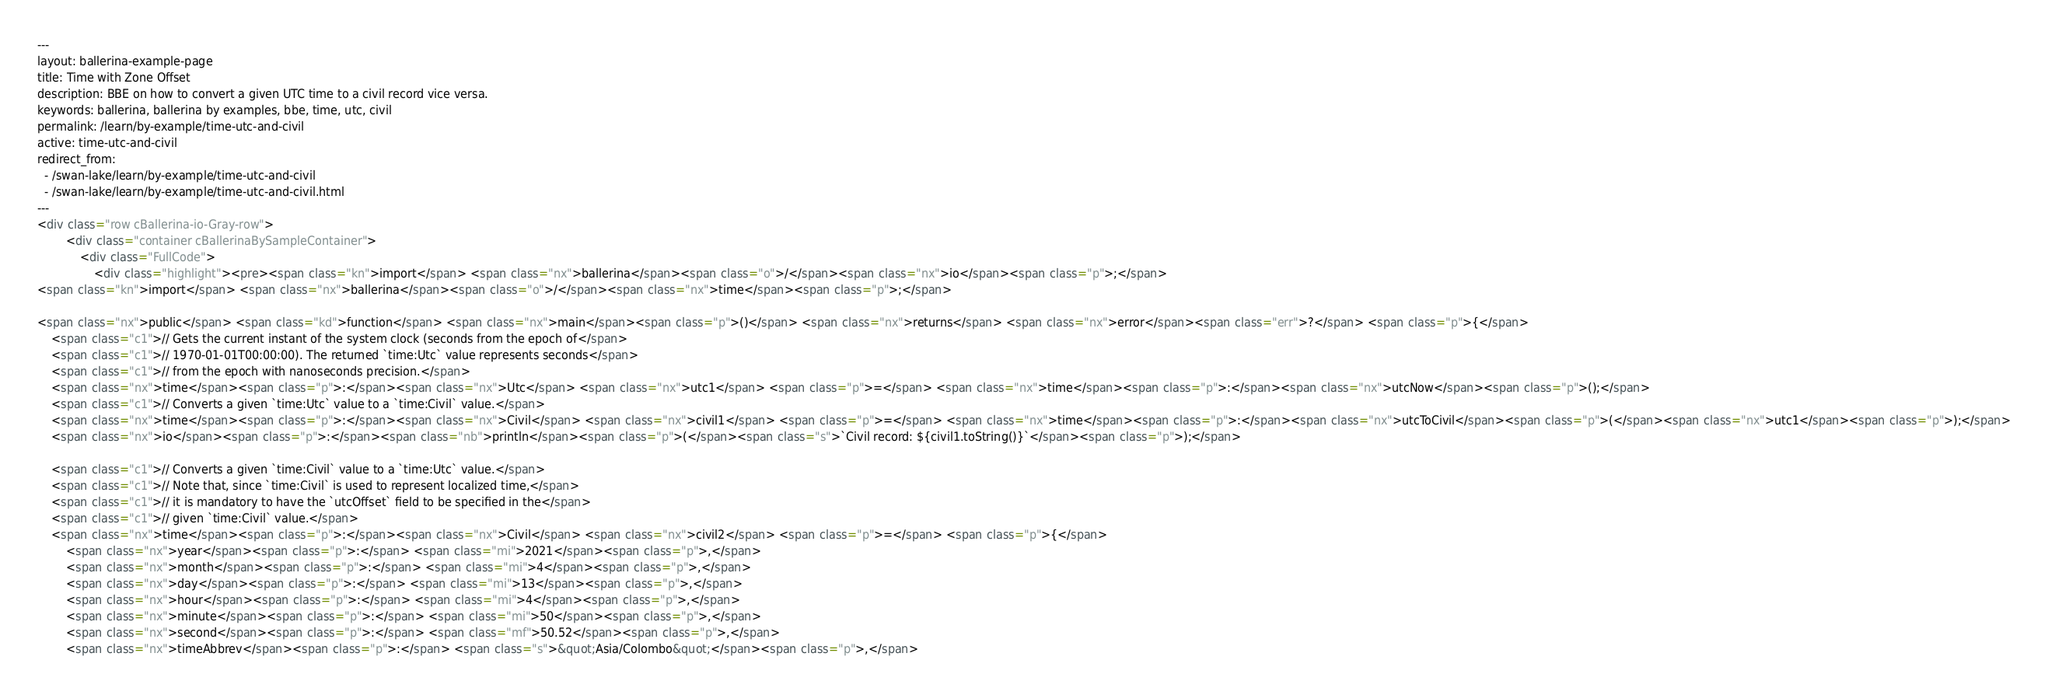Convert code to text. <code><loc_0><loc_0><loc_500><loc_500><_HTML_>---
layout: ballerina-example-page
title: Time with Zone Offset
description: BBE on how to convert a given UTC time to a civil record vice versa.
keywords: ballerina, ballerina by examples, bbe, time, utc, civil
permalink: /learn/by-example/time-utc-and-civil
active: time-utc-and-civil
redirect_from:
  - /swan-lake/learn/by-example/time-utc-and-civil
  - /swan-lake/learn/by-example/time-utc-and-civil.html
---
<div class="row cBallerina-io-Gray-row">
        <div class="container cBallerinaBySampleContainer">
            <div class="FullCode">
                <div class="highlight"><pre><span class="kn">import</span> <span class="nx">ballerina</span><span class="o">/</span><span class="nx">io</span><span class="p">;</span>
<span class="kn">import</span> <span class="nx">ballerina</span><span class="o">/</span><span class="nx">time</span><span class="p">;</span>

<span class="nx">public</span> <span class="kd">function</span> <span class="nx">main</span><span class="p">()</span> <span class="nx">returns</span> <span class="nx">error</span><span class="err">?</span> <span class="p">{</span>
    <span class="c1">// Gets the current instant of the system clock (seconds from the epoch of</span>
    <span class="c1">// 1970-01-01T00:00:00). The returned `time:Utc` value represents seconds</span>
    <span class="c1">// from the epoch with nanoseconds precision.</span>
    <span class="nx">time</span><span class="p">:</span><span class="nx">Utc</span> <span class="nx">utc1</span> <span class="p">=</span> <span class="nx">time</span><span class="p">:</span><span class="nx">utcNow</span><span class="p">();</span>
    <span class="c1">// Converts a given `time:Utc` value to a `time:Civil` value.</span>
    <span class="nx">time</span><span class="p">:</span><span class="nx">Civil</span> <span class="nx">civil1</span> <span class="p">=</span> <span class="nx">time</span><span class="p">:</span><span class="nx">utcToCivil</span><span class="p">(</span><span class="nx">utc1</span><span class="p">);</span>
    <span class="nx">io</span><span class="p">:</span><span class="nb">println</span><span class="p">(</span><span class="s">`Civil record: ${civil1.toString()}`</span><span class="p">);</span>

    <span class="c1">// Converts a given `time:Civil` value to a `time:Utc` value.</span>
    <span class="c1">// Note that, since `time:Civil` is used to represent localized time,</span>
    <span class="c1">// it is mandatory to have the `utcOffset` field to be specified in the</span>
    <span class="c1">// given `time:Civil` value.</span>
    <span class="nx">time</span><span class="p">:</span><span class="nx">Civil</span> <span class="nx">civil2</span> <span class="p">=</span> <span class="p">{</span>
        <span class="nx">year</span><span class="p">:</span> <span class="mi">2021</span><span class="p">,</span>
        <span class="nx">month</span><span class="p">:</span> <span class="mi">4</span><span class="p">,</span>
        <span class="nx">day</span><span class="p">:</span> <span class="mi">13</span><span class="p">,</span>
        <span class="nx">hour</span><span class="p">:</span> <span class="mi">4</span><span class="p">,</span>
        <span class="nx">minute</span><span class="p">:</span> <span class="mi">50</span><span class="p">,</span>
        <span class="nx">second</span><span class="p">:</span> <span class="mf">50.52</span><span class="p">,</span>
        <span class="nx">timeAbbrev</span><span class="p">:</span> <span class="s">&quot;Asia/Colombo&quot;</span><span class="p">,</span></code> 